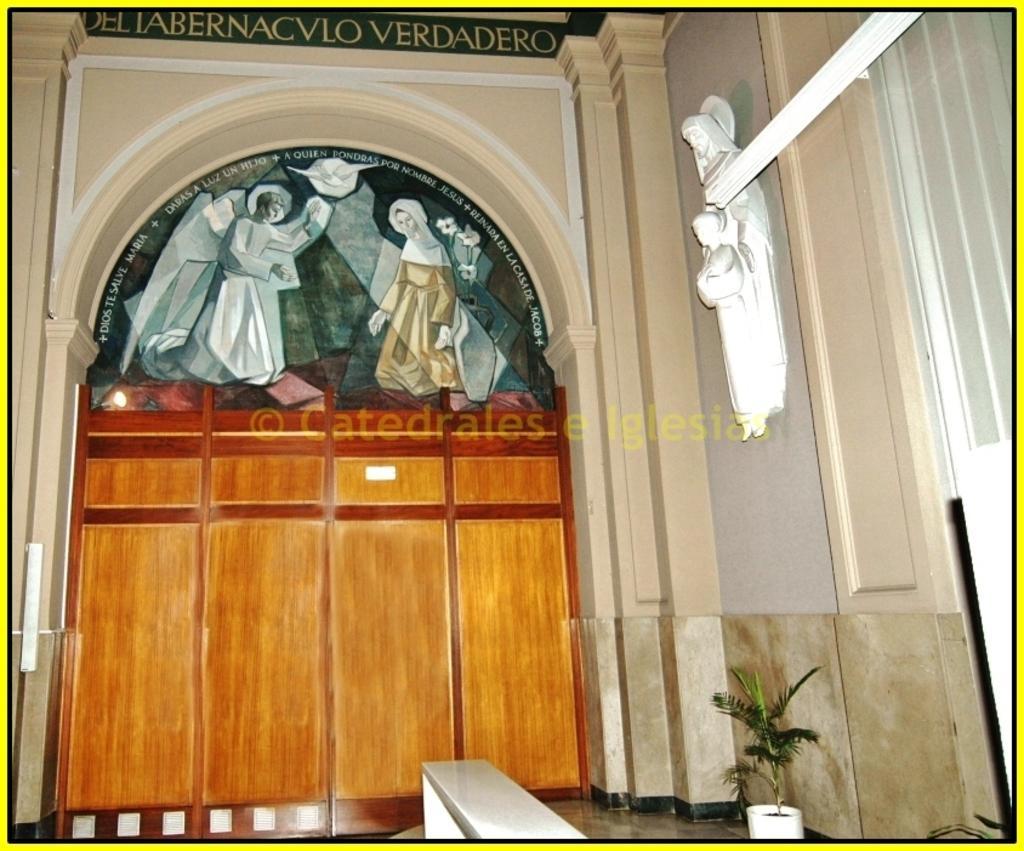Can you describe this image briefly? In the image we can see an arch. Here we can see sculptures and pictures of people. Here we can see the text, plant pots and the floor. 